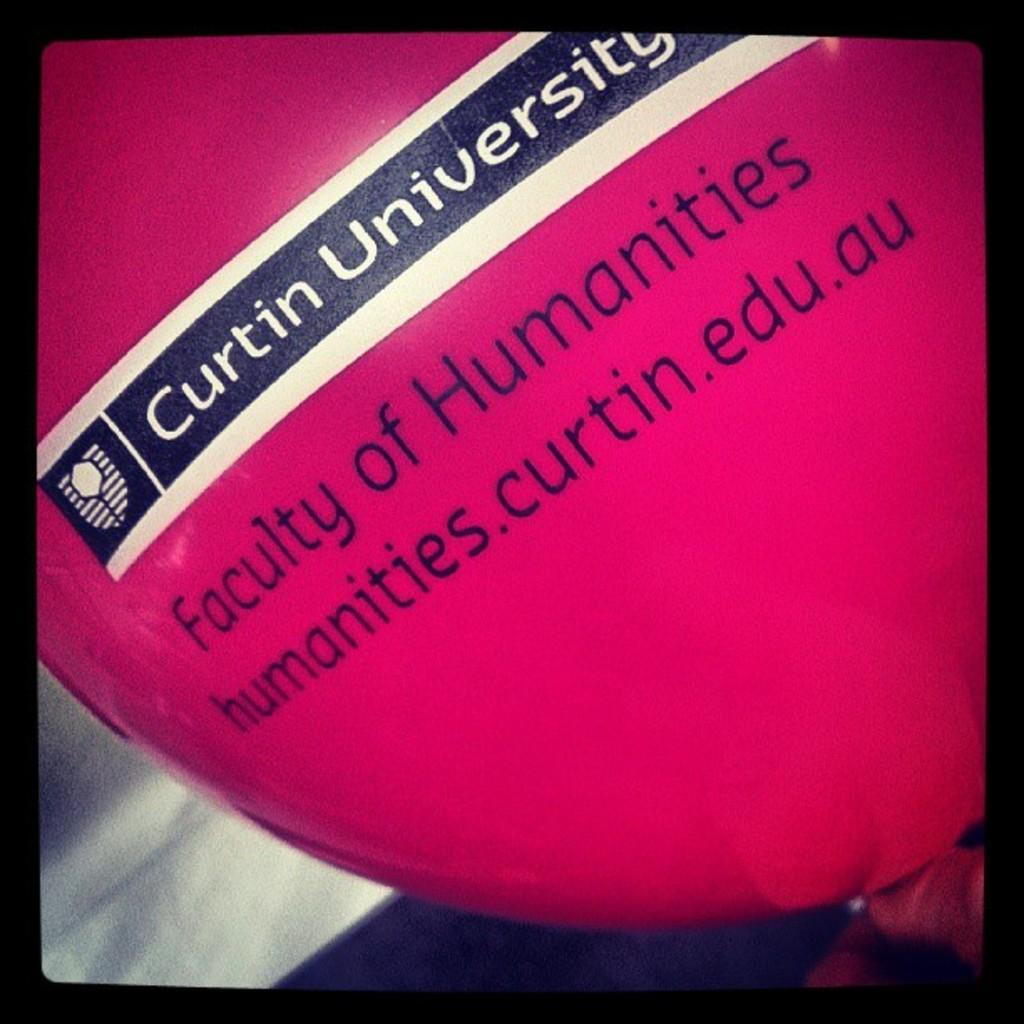What object can be seen floating in the image? There is a balloon in the image. What is unique about the balloon in the image? There is text written on the balloon. How many cherries are hanging from the crow's beak in the image? There is no crow or cherries present in the image. What type of animal is the giraffe in the image? There is no giraffe present in the image. 